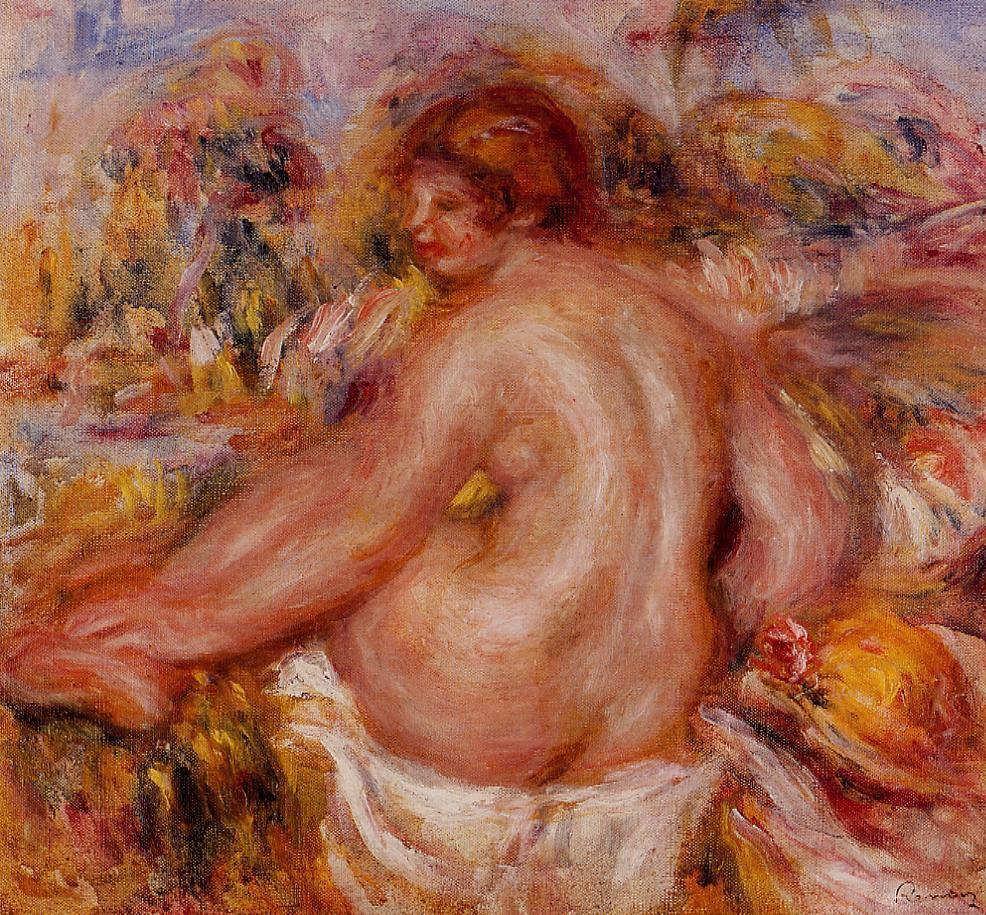How does this painting make you feel? This painting evokes a sense of calm and serenity. The warm colors and the fluid, graceful lines create an inviting and soothing atmosphere. It feels like a moment of peace and introspection, surrounded by natural beauty. Imagine a story behind the scene depicted in this painting. In a secluded garden, untouched by the haste of daily life, lived a woman named Isabelle. She was often found communing with nature, seeking solace and inspiration among the verdant leaves and vibrant blooms. One fine spring morning, Isabelle decided to bask in the early sun's embrace, shedding her constraints and sitting amidst the flowers. As she sat, the blossoms around her seemed to come alive in a symphony of color, their petals shimmering in harmony with her fiery red hair. Surrounded by nature’s splendor, Isabelle felt a deep connection to the earth, her spirit intertwined with the world around her, finding peace and a profound sense of belonging. The scene is not just a portrayal of tranquility but a testament to the intimate relationship between humanity and nature, capturing a woman's serene moment of unity with the natural world. 